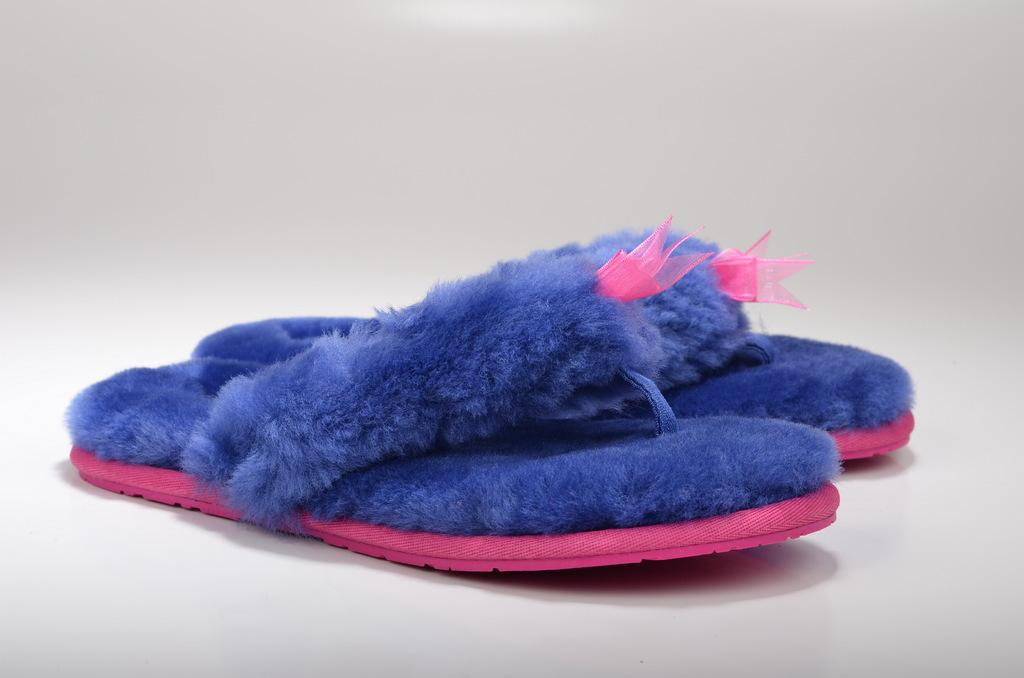What type of footwear can be seen in the image? There are slippers on the surface in the image. What colors are the slippers? The slippers are pink and blue in color. What is the color of the background in the image? The background of the image is white. What type of farm equipment can be seen in the image? There is no farm equipment present in the image; it features slippers on a surface with a white background. How many dolls are visible in the image? There are no dolls present in the image. 